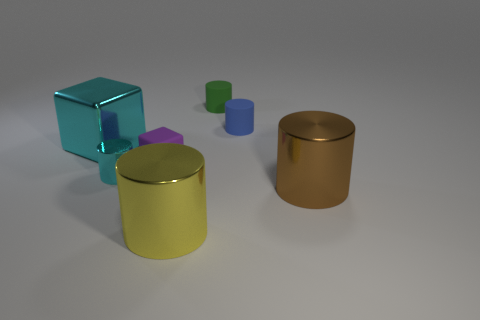What number of other things are there of the same material as the tiny purple object
Ensure brevity in your answer.  2. Does the big object that is to the left of the big yellow cylinder have the same shape as the small green object?
Provide a short and direct response. No. Are there fewer matte cylinders than tiny green rubber things?
Ensure brevity in your answer.  No. How many other metallic cylinders have the same color as the small shiny cylinder?
Provide a short and direct response. 0. What material is the block that is the same color as the small shiny cylinder?
Your answer should be very brief. Metal. Is the color of the rubber block the same as the cylinder in front of the brown metal cylinder?
Offer a very short reply. No. Are there more large brown spheres than blue cylinders?
Offer a terse response. No. There is a blue matte thing that is the same shape as the big brown shiny object; what is its size?
Ensure brevity in your answer.  Small. Is the big brown cylinder made of the same material as the tiny object in front of the purple object?
Offer a very short reply. Yes. How many things are blue rubber blocks or yellow metal things?
Make the answer very short. 1. 